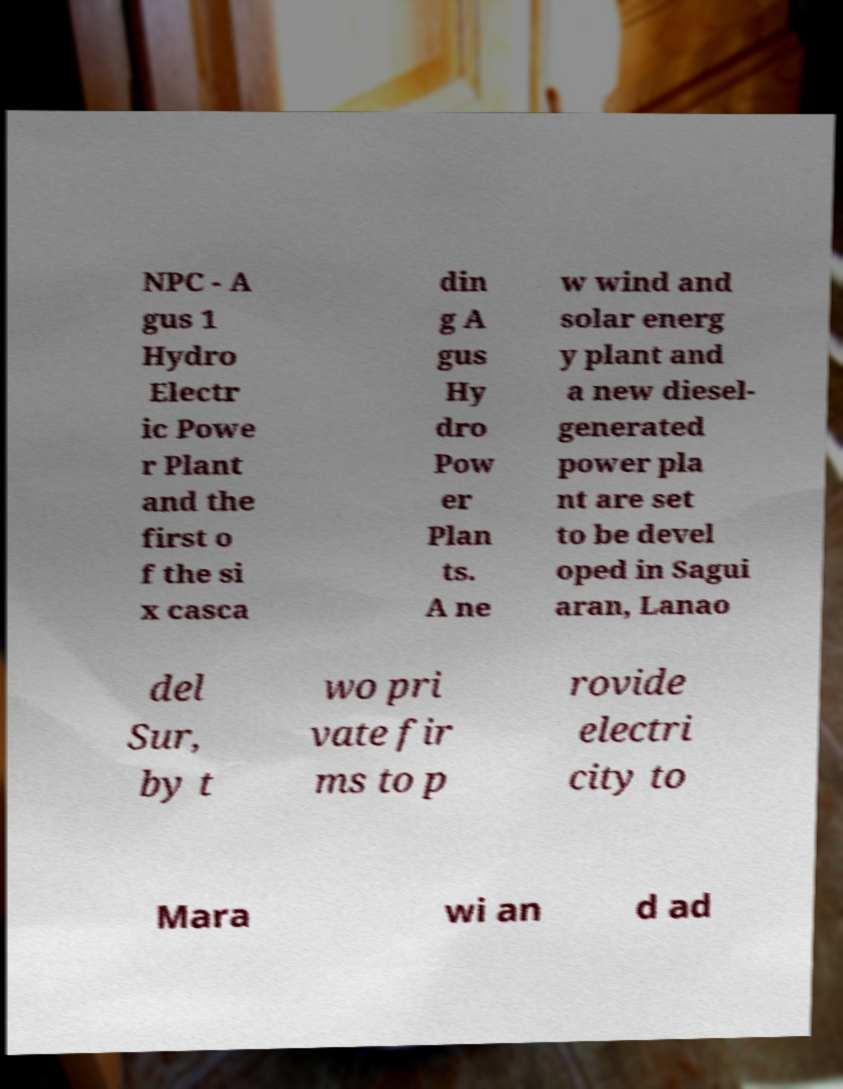Please read and relay the text visible in this image. What does it say? NPC - A gus 1 Hydro Electr ic Powe r Plant and the first o f the si x casca din g A gus Hy dro Pow er Plan ts. A ne w wind and solar energ y plant and a new diesel- generated power pla nt are set to be devel oped in Sagui aran, Lanao del Sur, by t wo pri vate fir ms to p rovide electri city to Mara wi an d ad 